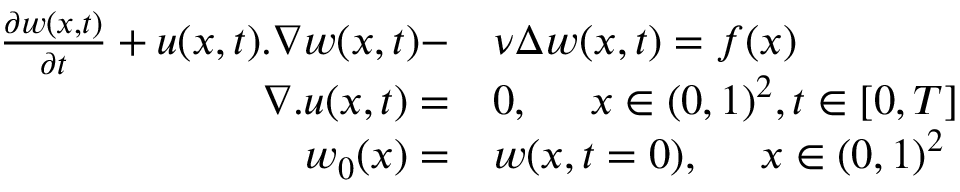<formula> <loc_0><loc_0><loc_500><loc_500>\begin{array} { r l } { \frac { \partial w ( x , t ) } { \partial t } + u ( x , t ) . \nabla w ( x , t ) - } & \nu \Delta w ( x , t ) = f ( x ) } \\ { \nabla . u ( x , t ) = } & 0 , x \in ( 0 , 1 ) ^ { 2 } , t \in [ 0 , T ] } \\ { w _ { 0 } ( x ) = } & w ( x , t = 0 ) , x \in ( 0 , 1 ) ^ { 2 } } \end{array}</formula> 